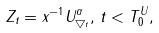Convert formula to latex. <formula><loc_0><loc_0><loc_500><loc_500>Z _ { t } = x ^ { - 1 } U ^ { \alpha } _ { \bigtriangledown _ { t } } , \, t < T _ { 0 } ^ { U } ,</formula> 